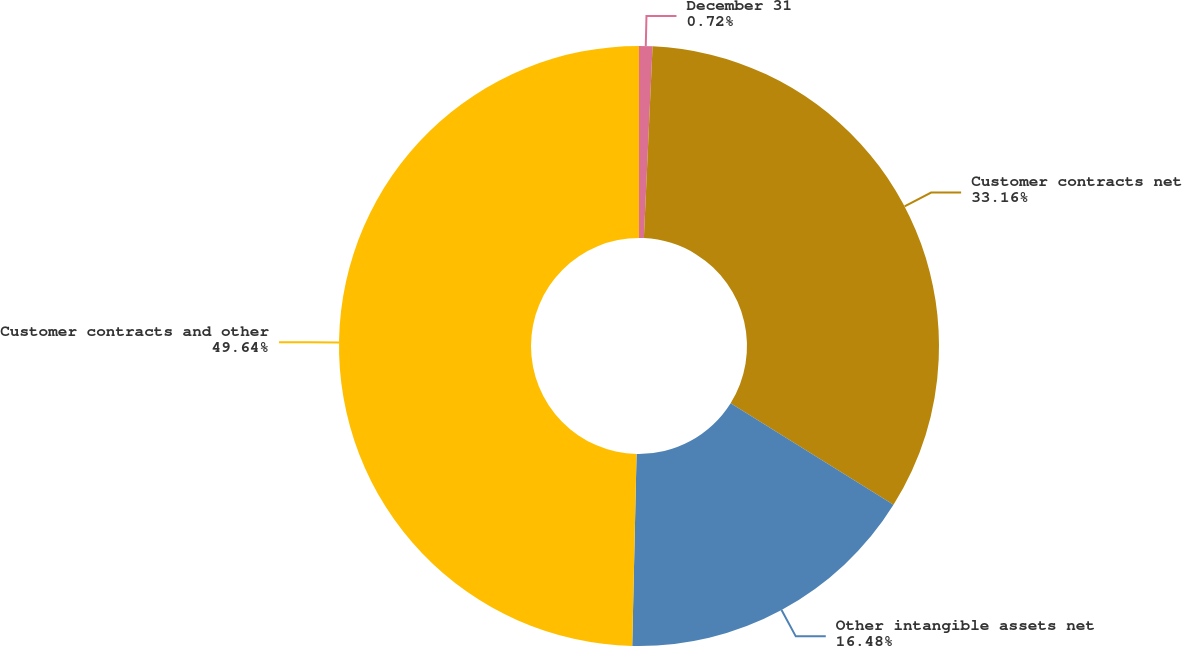Convert chart. <chart><loc_0><loc_0><loc_500><loc_500><pie_chart><fcel>December 31<fcel>Customer contracts net<fcel>Other intangible assets net<fcel>Customer contracts and other<nl><fcel>0.72%<fcel>33.16%<fcel>16.48%<fcel>49.64%<nl></chart> 